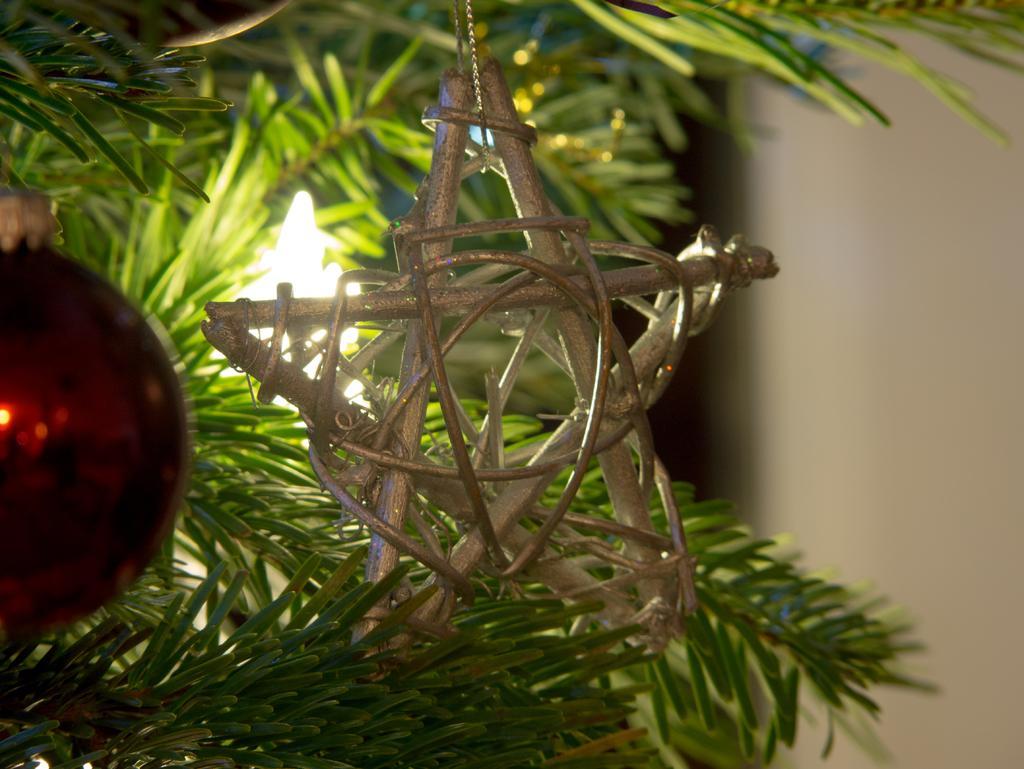Could you give a brief overview of what you see in this image? In the foreground of this picture, there is a star and a red ball hanging to a tree and there is a light and wall in the background. 